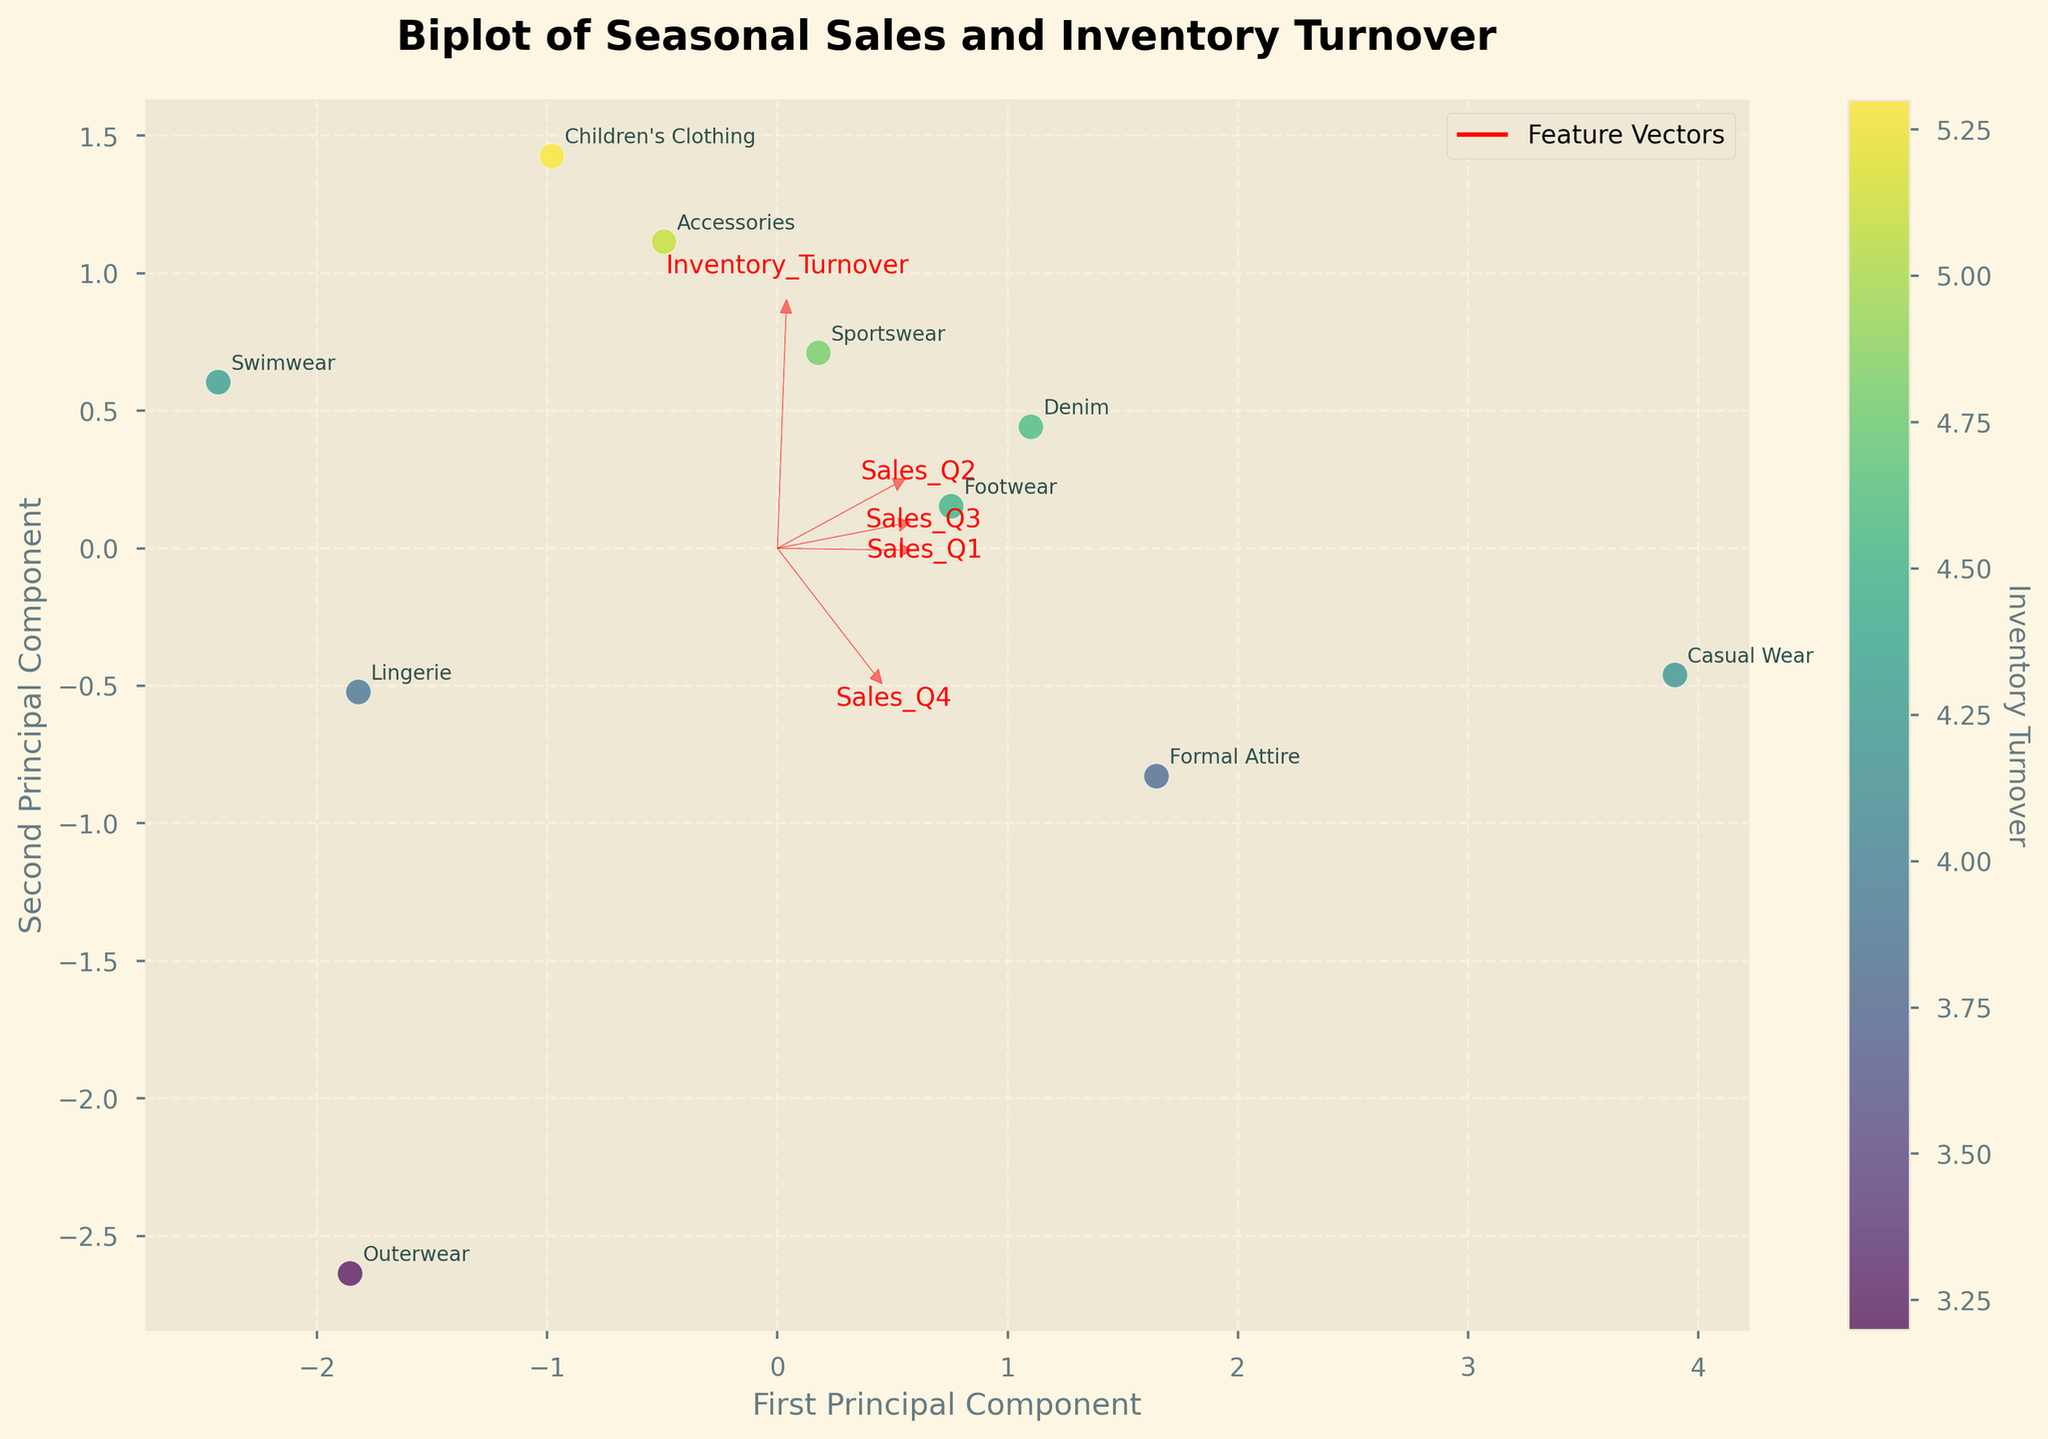what is the title of the figure? The title of the figure is usually placed prominently at the top of the chart. Observing the figure, we see the title written in bold.
Answer: Biplot of Seasonal Sales and Inventory Turnover Which product shows the lowest inventory turnover? Inventory turnover is indicated by the color of the scatter points. By examining the color bar and the scatter points, the darkest color represents the lowest turnover. The point for "Outerwear" is the darkest.
Answer: Outerwear Which two products are closest to each other in the biplot? By observing the distance between the points representing different products, we can determine proximity. "Footwear" and "Denim" are very close to each other.
Answer: Footwear and Denim What is the direction and length of the vector for Sales_Q4? By looking at the red arrows emanating from the origin, the vector for Sales_Q4 is the longest arrow pointing towards the positive quadrant, indicating its significant influence on the first principal component. The direction is also towards the upper right.
Answer: Positive direction, longest arrow Which feature has the largest influence on the second principal component? The second principal component is the vertical axis. The arrow contributing most vertically to the second axis represents the greatest influence. The vector for "Sales_Q4" appears to be the longest pointing towards the upper part of both axes but also contributes significantly to PC2.
Answer: Sales_Q4 How does the inventory turnover of casual wear compare to formal attire? The scatter plots are color-coded for inventory turnover rates. Comparing the shades of "Casual Wear" and "Formal Attire," both points appear similar, indicating close turnover rates.
Answer: Close to each other What trend can be derived from the vectors' direction in terms of sales for different quarters? Most sales-related vectors (Sales_Q1 to Sales_Q4) point in a similar direction towards the right, indicating that higher sales across different quarters have a similar effect on the principal components.
Answer: Similar effect Which product has the highest combined sales in all quarters? Combined sales can be implied by the position of points towards the direction of Sales_Q4 vector, as it has the highest weight. "Casual Wear" is positioned farthest along this direction.
Answer: Casual Wear Is there a strong correlation between any specific sales quarter and inventory turnover? By looking at the angles between vectors, the smaller the angle, the higher the correlation. Vectors of Sale_Q1, Sales_Q2, and Sales_Q3 are closer to the Inventory Turnover vector indicating a correlation.
Answer: Sales Q1, Q2, Q3 